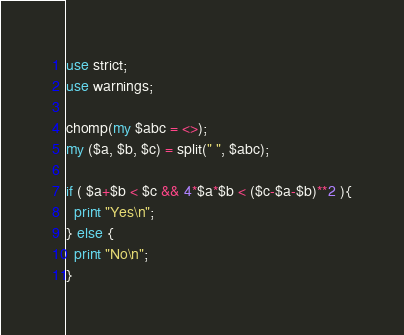Convert code to text. <code><loc_0><loc_0><loc_500><loc_500><_Perl_>use strict;
use warnings;

chomp(my $abc = <>);
my ($a, $b, $c) = split(" ", $abc);

if ( $a+$b < $c && 4*$a*$b < ($c-$a-$b)**2 ){
  print "Yes\n";
} else {
  print "No\n";
}
</code> 